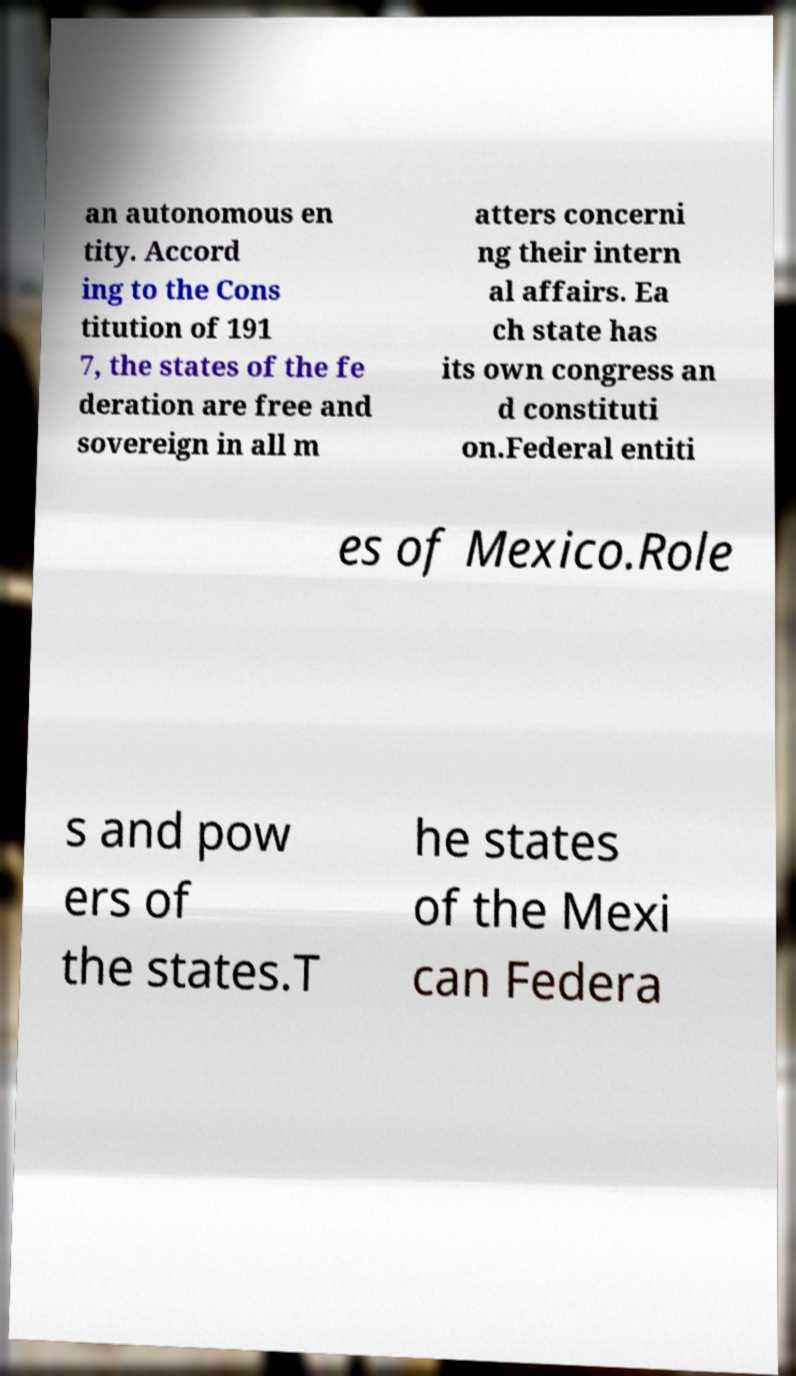Can you accurately transcribe the text from the provided image for me? an autonomous en tity. Accord ing to the Cons titution of 191 7, the states of the fe deration are free and sovereign in all m atters concerni ng their intern al affairs. Ea ch state has its own congress an d constituti on.Federal entiti es of Mexico.Role s and pow ers of the states.T he states of the Mexi can Federa 